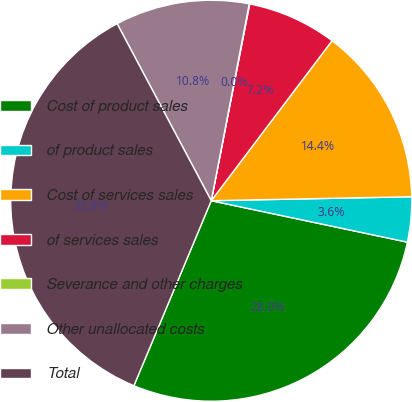Convert chart. <chart><loc_0><loc_0><loc_500><loc_500><pie_chart><fcel>Cost of product sales<fcel>of product sales<fcel>Cost of services sales<fcel>of services sales<fcel>Severance and other charges<fcel>Other unallocated costs<fcel>Total<nl><fcel>27.99%<fcel>3.63%<fcel>14.39%<fcel>7.22%<fcel>0.04%<fcel>10.81%<fcel>35.92%<nl></chart> 